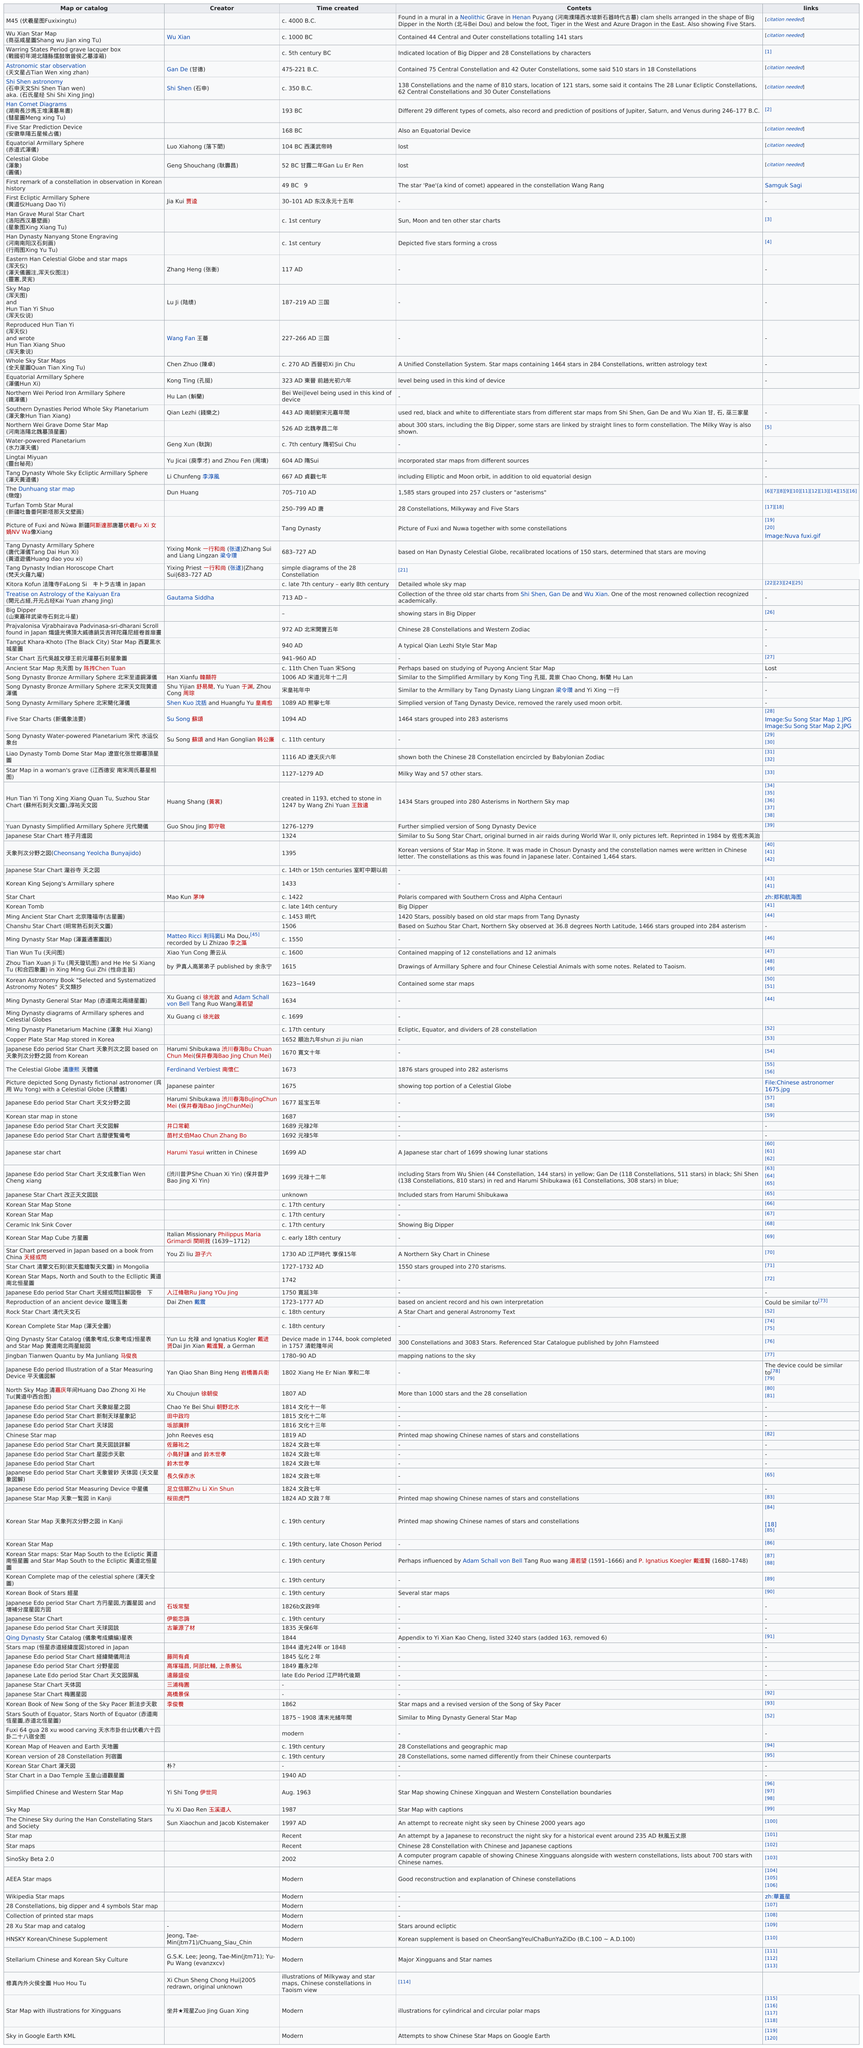Indicate a few pertinent items in this graphic. It is uncertain whether Xu Guangci or Su Song created the Five Star Charts in 1094 AD. Su Song is known as the inventor of the first seismic detector, but there is no evidence to support his creation of the Five Star Charts. After the creation of the equatorial armillary sphere, three additional celestial instruments were developed: the celestial globe, the first constellation observation in Korean history, and the first ecliptic armillary sphere. The first map or catalog was created around 4000 B.C. The celestial globe was created earlier than the Han grave mural star chart. The M45 (Fuxixingtu) star map was the first Chinese star map known to have been created. 